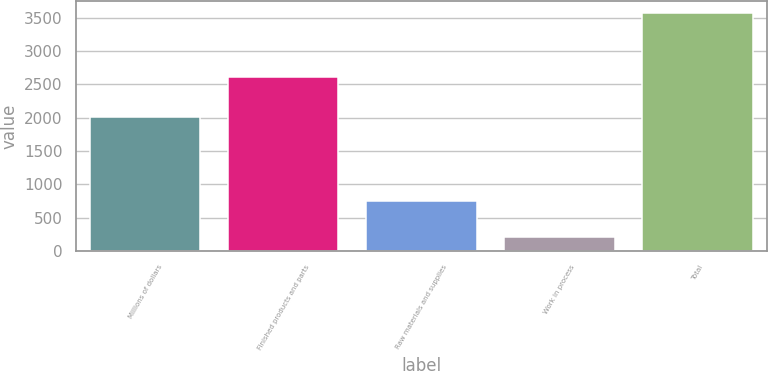<chart> <loc_0><loc_0><loc_500><loc_500><bar_chart><fcel>Millions of dollars<fcel>Finished products and parts<fcel>Raw materials and supplies<fcel>Work in process<fcel>Total<nl><fcel>2014<fcel>2606<fcel>754<fcel>211<fcel>3571<nl></chart> 